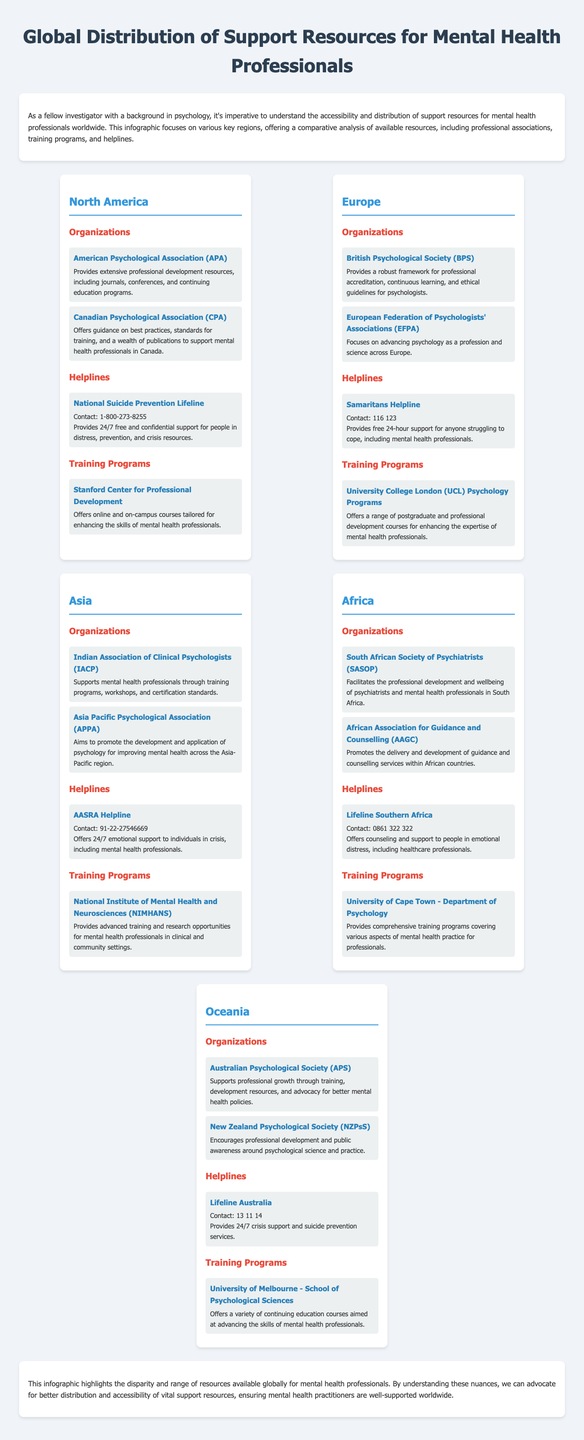What organization provides professional development resources in North America? The American Psychological Association (APA) is mentioned as providing extensive professional development resources.
Answer: American Psychological Association (APA) What is the contact number for the National Suicide Prevention Lifeline? The document lists the contact number for the National Suicide Prevention Lifeline as 1-800-273-8255.
Answer: 1-800-273-8255 Which European organization focuses on the accreditation of psychological professionals? The British Psychological Society (BPS) is highlighted as providing a robust framework for professional accreditation.
Answer: British Psychological Society (BPS) What type of support does the Lifeline Australia offer? According to the document, Lifeline Australia provides 24/7 crisis support and suicide prevention services.
Answer: Crisis support and suicide prevention services How many regions are covered in the infographic? The infographic covers five key regions: North America, Europe, Asia, Africa, and Oceania.
Answer: Five What training program is associated with the University of Cape Town? The document states that the University of Cape Town offers comprehensive training programs covering various aspects of mental health practice for professionals.
Answer: Department of Psychology Which helpline in Asia provides 24/7 emotional support? AASRA Helpline is noted in the document as offering 24/7 emotional support to individuals in crisis.
Answer: AASRA Helpline What is the main purpose of the infographic? The infographic aims to highlight the disparity and range of resources available globally for mental health professionals.
Answer: Highlight disparity and range of resources 